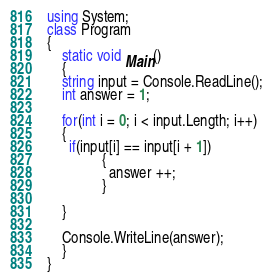<code> <loc_0><loc_0><loc_500><loc_500><_C#_>using System;
class Program
{
	static void Main()
	{
	string input = Console.ReadLine();
	int answer = 1;
    
    for(int i = 0; i < input.Length; i++)
    {
      if(input[i] == input[i + 1])
               {
                 answer ++;
               }
      
    }
      
	Console.WriteLine(answer);
	}
}</code> 